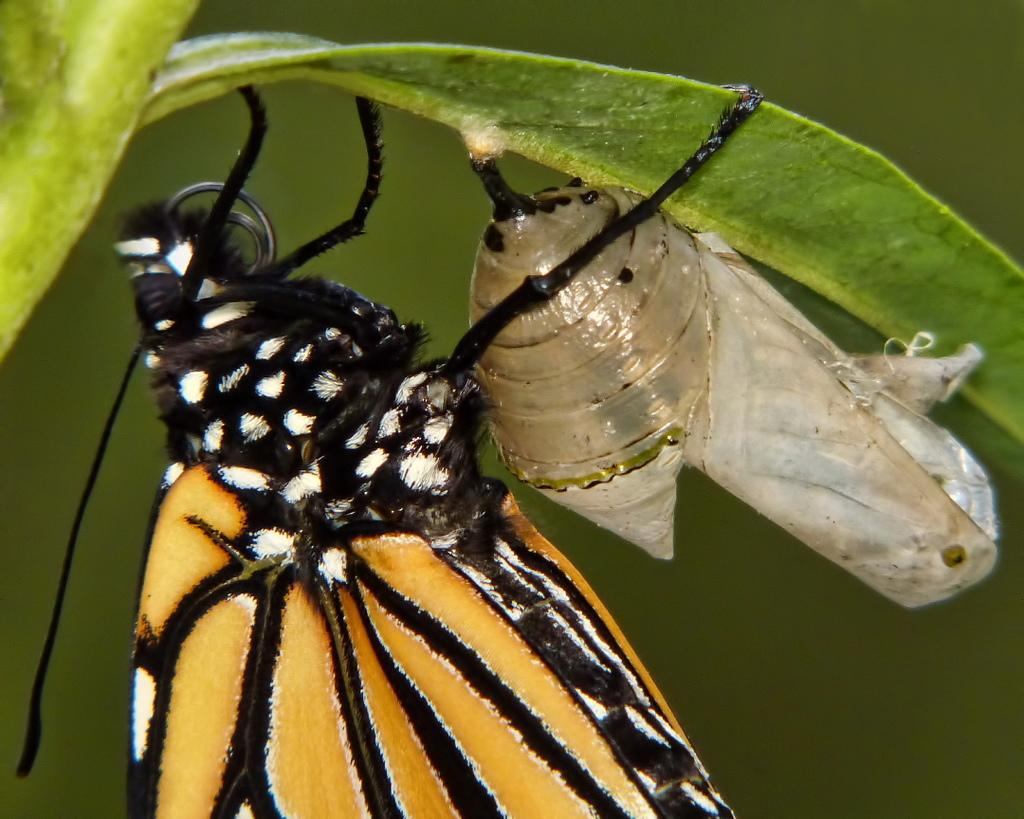What is the main subject of the image? There is an insect on a leaf in the image. Can you describe the background of the image? The background of the image is blurred. What type of fruit is being harvested at the seashore in the image? There is no seashore or fruit present in the image; it features an insect on a leaf with a blurred background. 